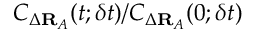<formula> <loc_0><loc_0><loc_500><loc_500>C _ { \Delta R _ { A } } ( t ; \delta t ) / C _ { \Delta R _ { A } } ( 0 ; \delta t )</formula> 